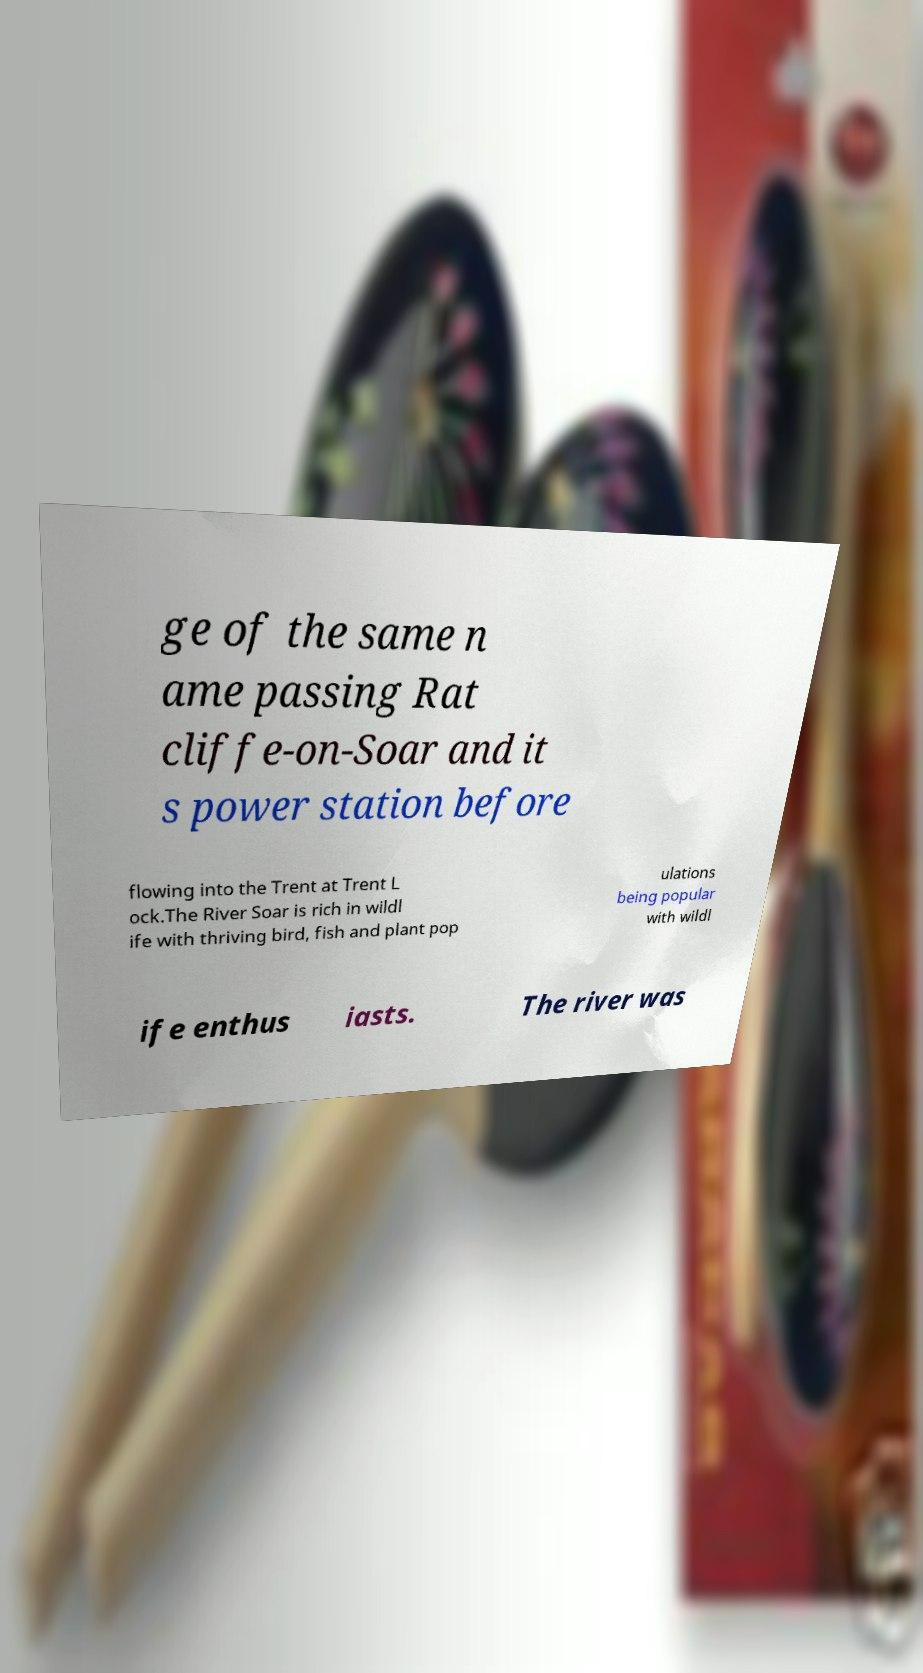There's text embedded in this image that I need extracted. Can you transcribe it verbatim? ge of the same n ame passing Rat cliffe-on-Soar and it s power station before flowing into the Trent at Trent L ock.The River Soar is rich in wildl ife with thriving bird, fish and plant pop ulations being popular with wildl ife enthus iasts. The river was 